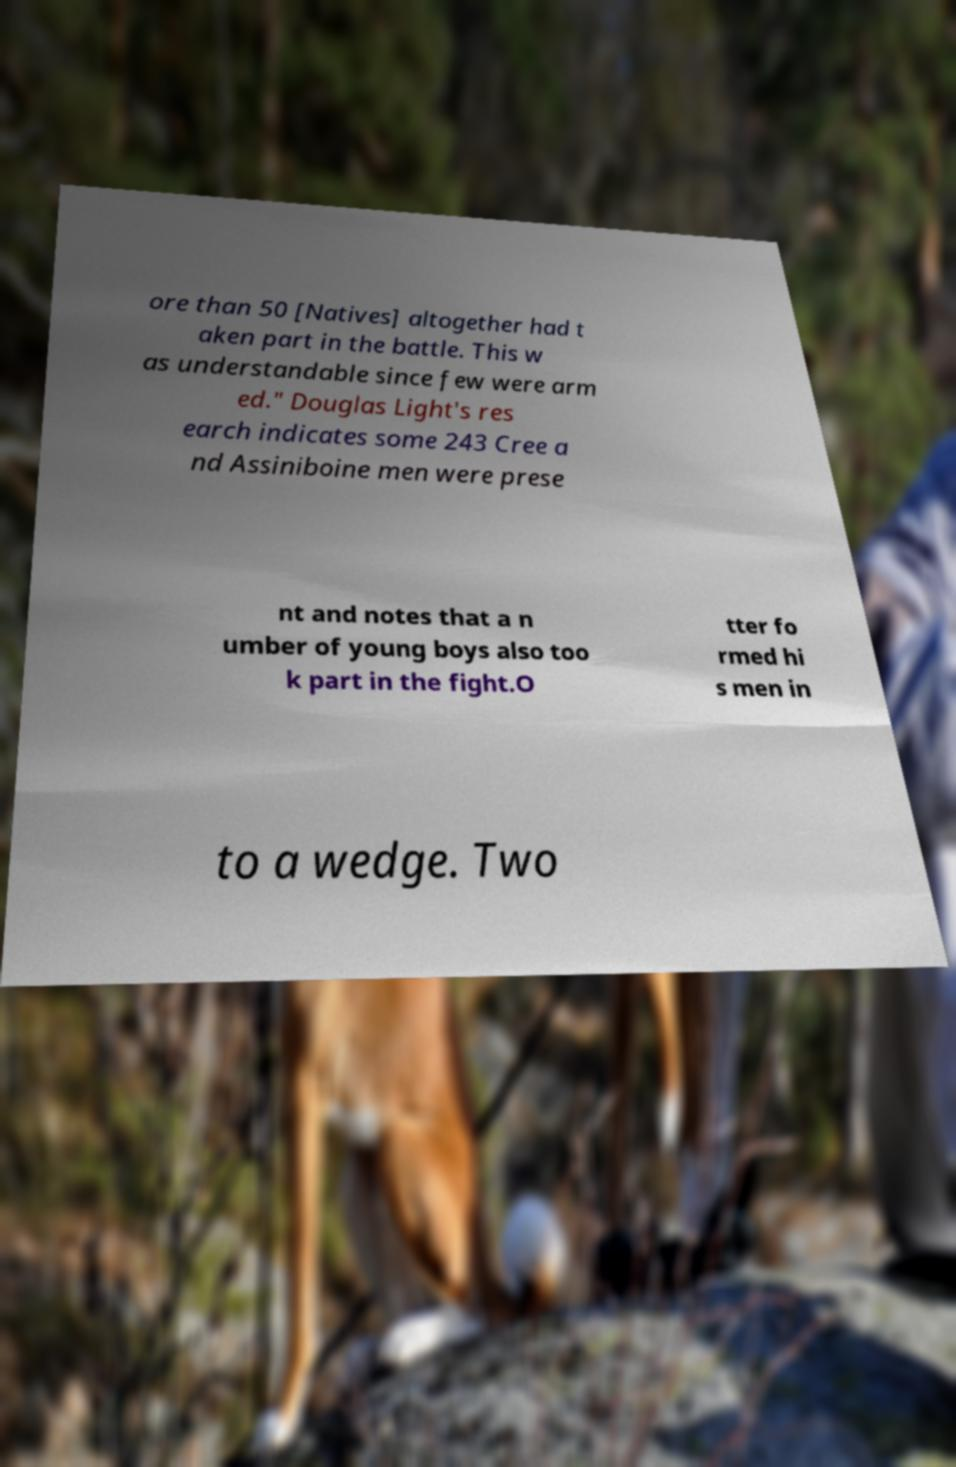For documentation purposes, I need the text within this image transcribed. Could you provide that? ore than 50 [Natives] altogether had t aken part in the battle. This w as understandable since few were arm ed." Douglas Light's res earch indicates some 243 Cree a nd Assiniboine men were prese nt and notes that a n umber of young boys also too k part in the fight.O tter fo rmed hi s men in to a wedge. Two 